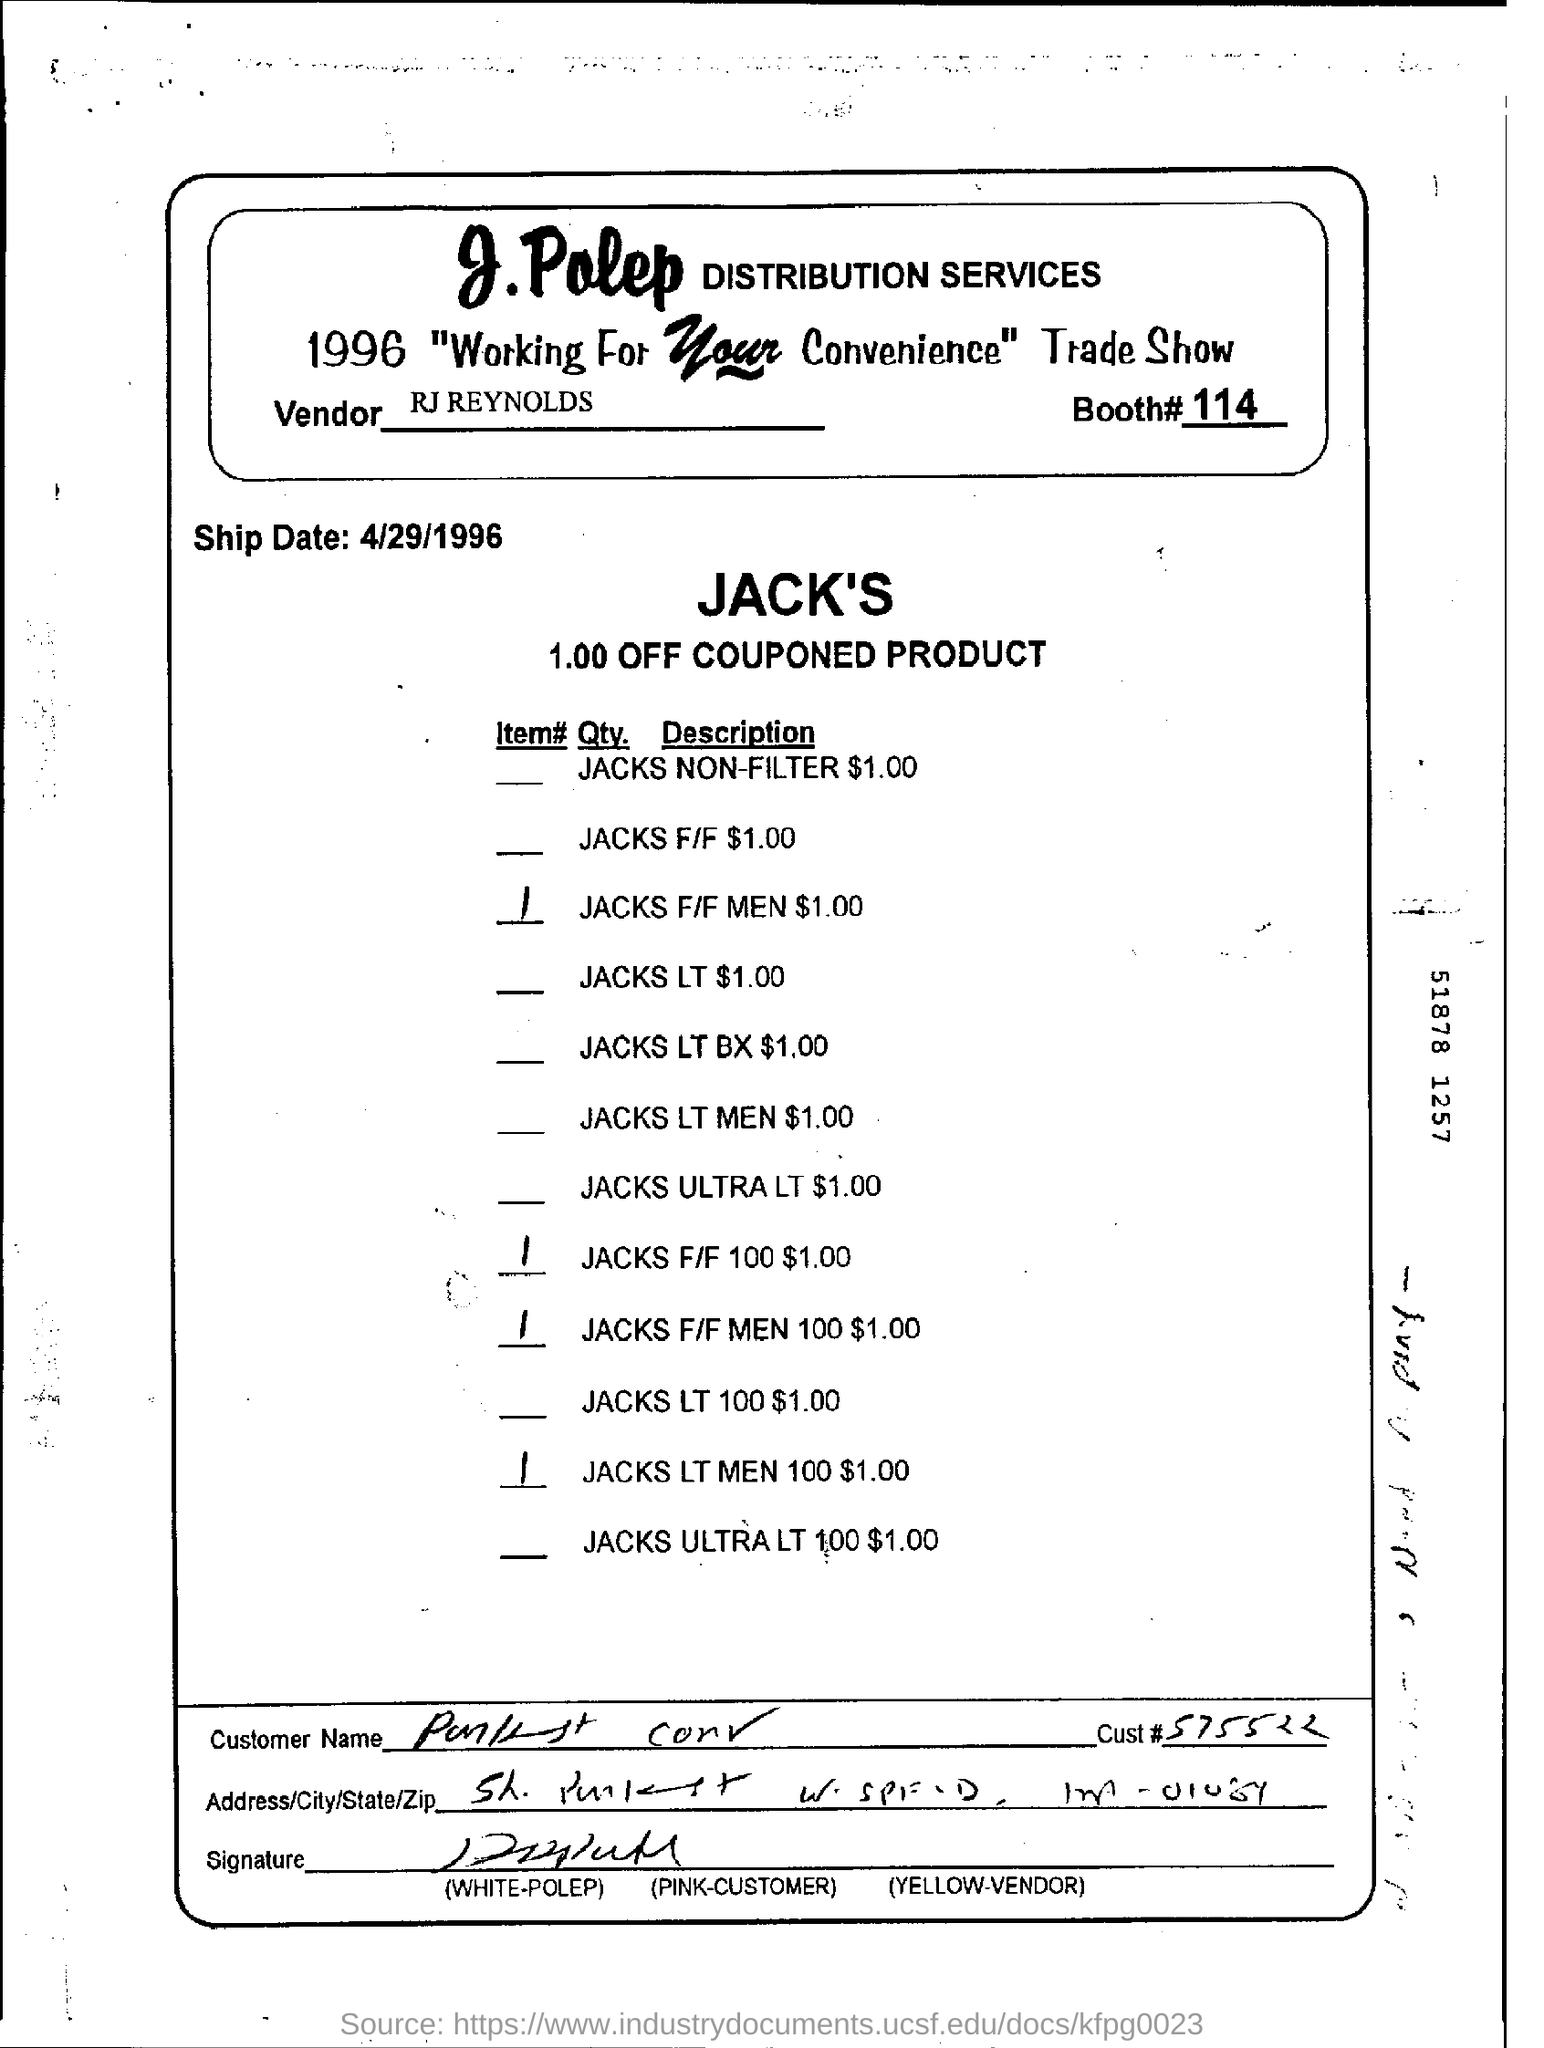Mention a couple of crucial points in this snapshot. The booth number mentioned is 114. 